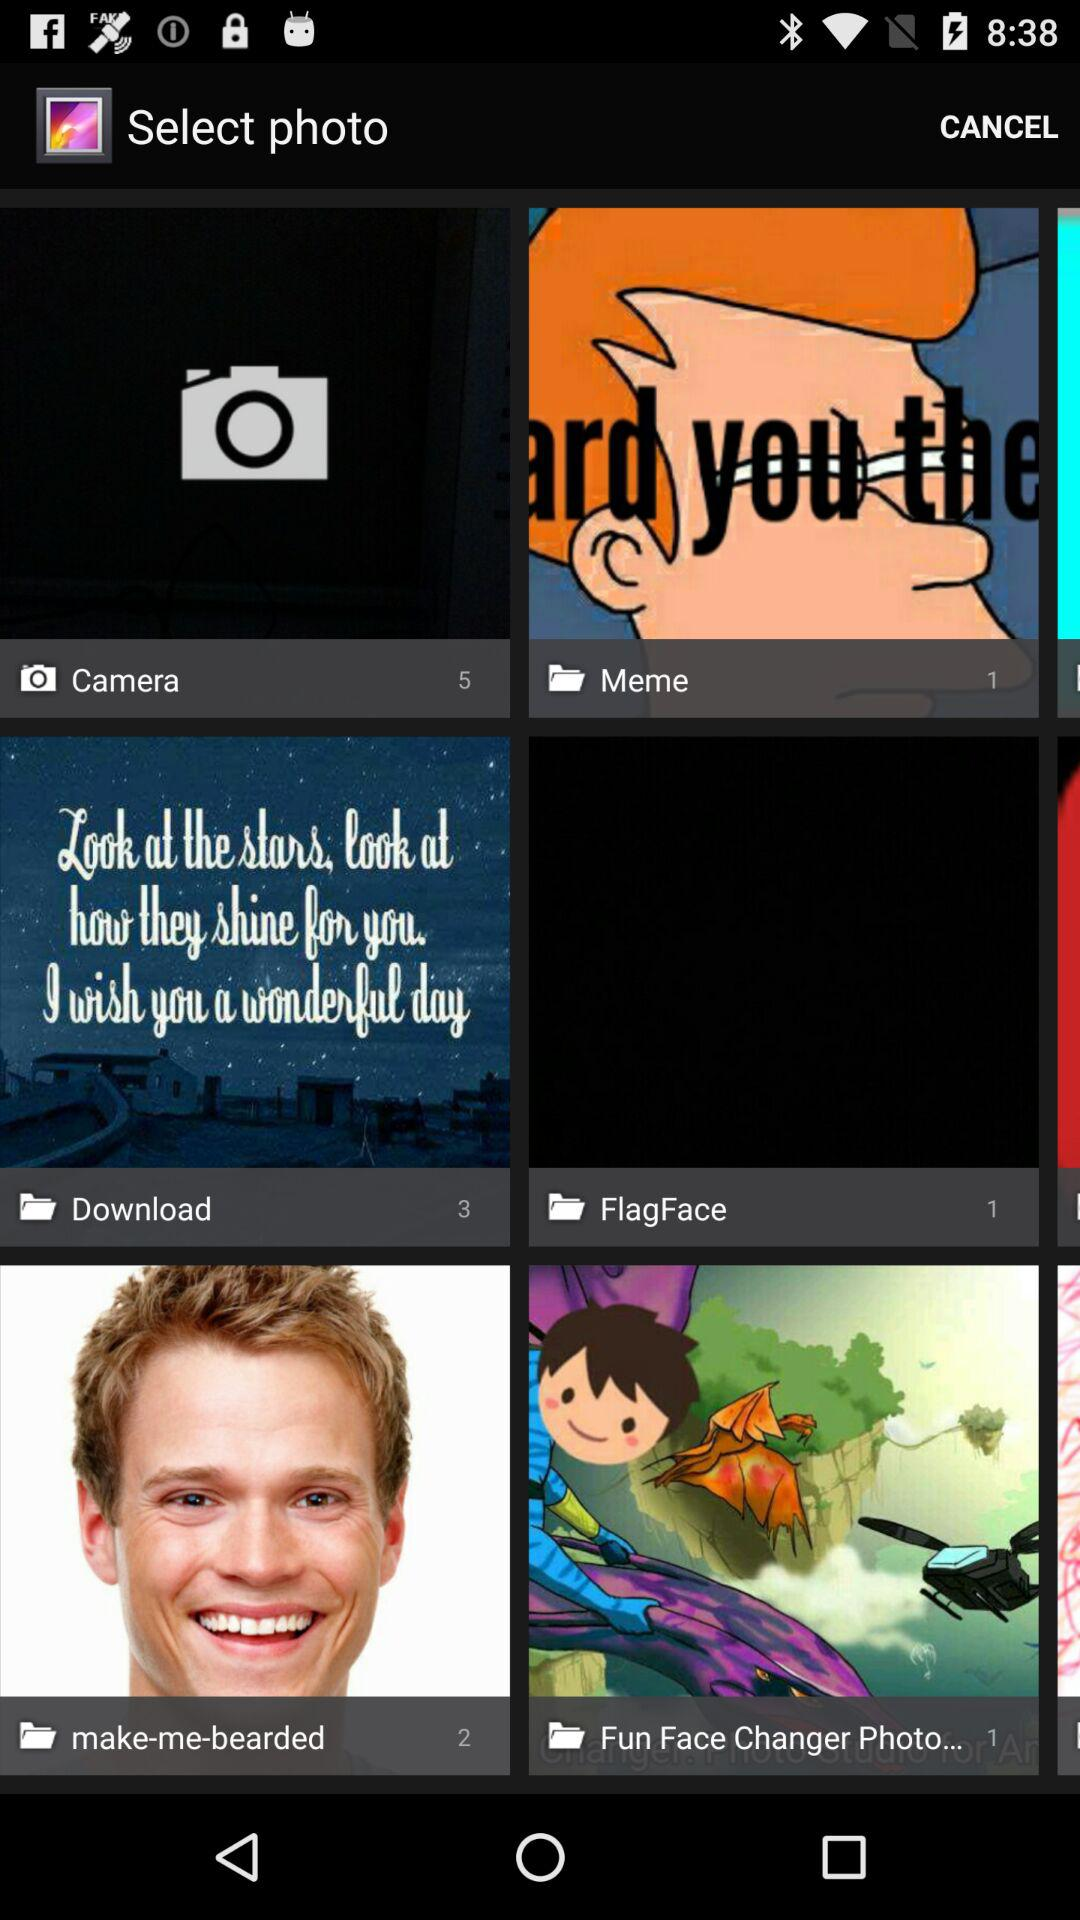How many photos are downloaded? There are 3 downloaded photos. 